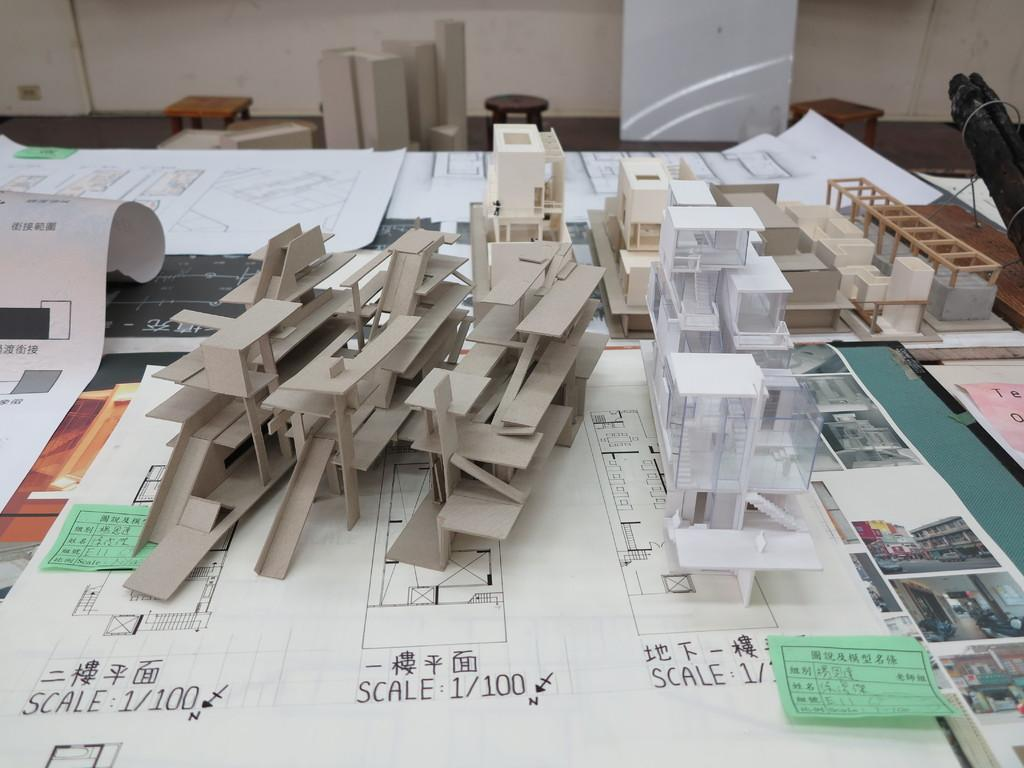Provide a one-sentence caption for the provided image. Pieces of building models are stacked on a table, and they are at a scale of 1/100. 